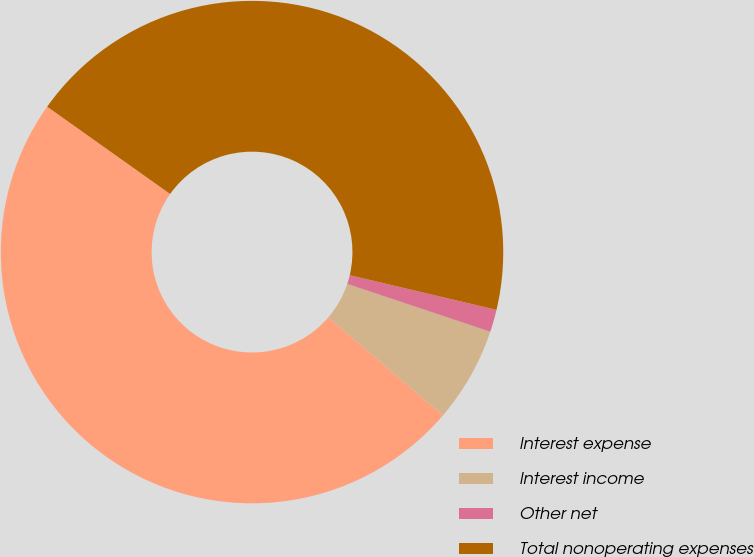<chart> <loc_0><loc_0><loc_500><loc_500><pie_chart><fcel>Interest expense<fcel>Interest income<fcel>Other net<fcel>Total nonoperating expenses<nl><fcel>48.56%<fcel>6.13%<fcel>1.44%<fcel>43.87%<nl></chart> 